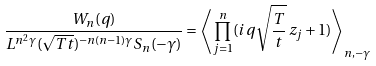Convert formula to latex. <formula><loc_0><loc_0><loc_500><loc_500>\frac { W _ { n } ( q ) } { L ^ { n ^ { 2 } \gamma } ( \sqrt { T t } ) ^ { - n ( n - 1 ) \gamma } S _ { n } ( - \gamma ) } = \left \langle \prod _ { j = 1 } ^ { n } ( i q \sqrt { \frac { T } { t } } \, z _ { j } + 1 ) \right \rangle _ { n , - \gamma }</formula> 